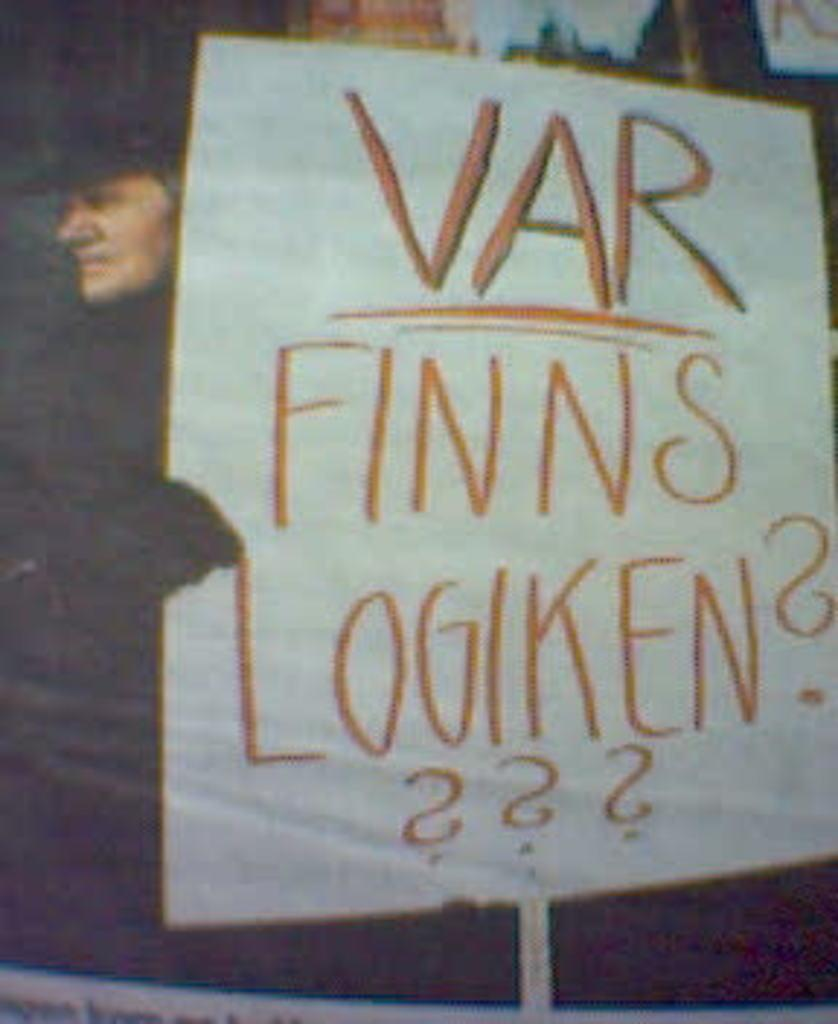What is the main subject of the image? There is a person in the image. What is the person holding in the image? The person is holding a board. What is written on the board? The board has writing on it, which says "Var finns logiken??". Can you tell me how many lamps are visible in the image? There are no lamps present in the image. What type of trail can be seen in the image? There is no trail present in the image. 